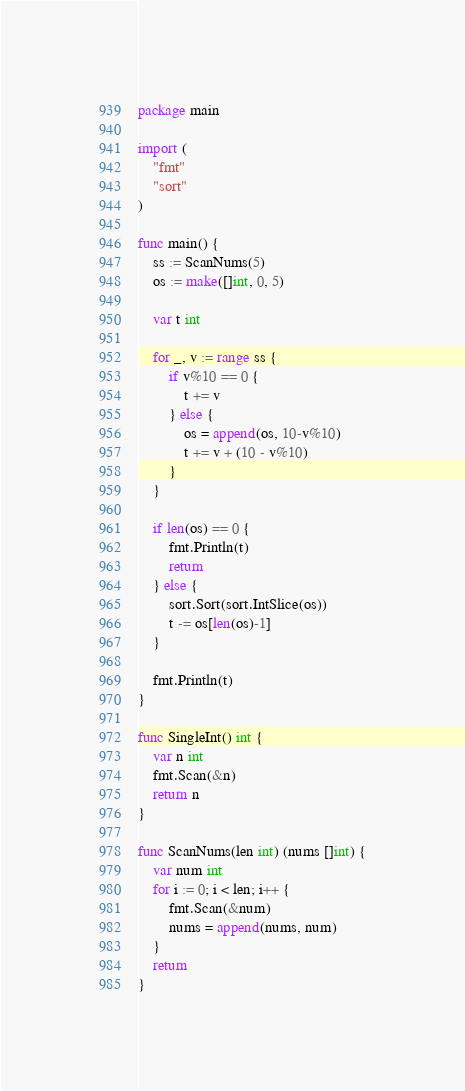<code> <loc_0><loc_0><loc_500><loc_500><_Go_>package main

import (
	"fmt"
	"sort"
)

func main() {
	ss := ScanNums(5)
	os := make([]int, 0, 5)

	var t int

	for _, v := range ss {
		if v%10 == 0 {
			t += v
		} else {
			os = append(os, 10-v%10)
			t += v + (10 - v%10)
		}
	}

	if len(os) == 0 {
		fmt.Println(t)
		return
	} else {
		sort.Sort(sort.IntSlice(os))
		t -= os[len(os)-1]
	}

	fmt.Println(t)
}

func SingleInt() int {
	var n int
	fmt.Scan(&n)
	return n
}

func ScanNums(len int) (nums []int) {
	var num int
	for i := 0; i < len; i++ {
		fmt.Scan(&num)
		nums = append(nums, num)
	}
	return
}
</code> 